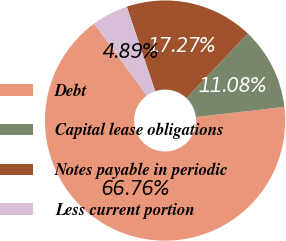Convert chart. <chart><loc_0><loc_0><loc_500><loc_500><pie_chart><fcel>Debt<fcel>Capital lease obligations<fcel>Notes payable in periodic<fcel>Less current portion<nl><fcel>66.76%<fcel>11.08%<fcel>17.27%<fcel>4.89%<nl></chart> 